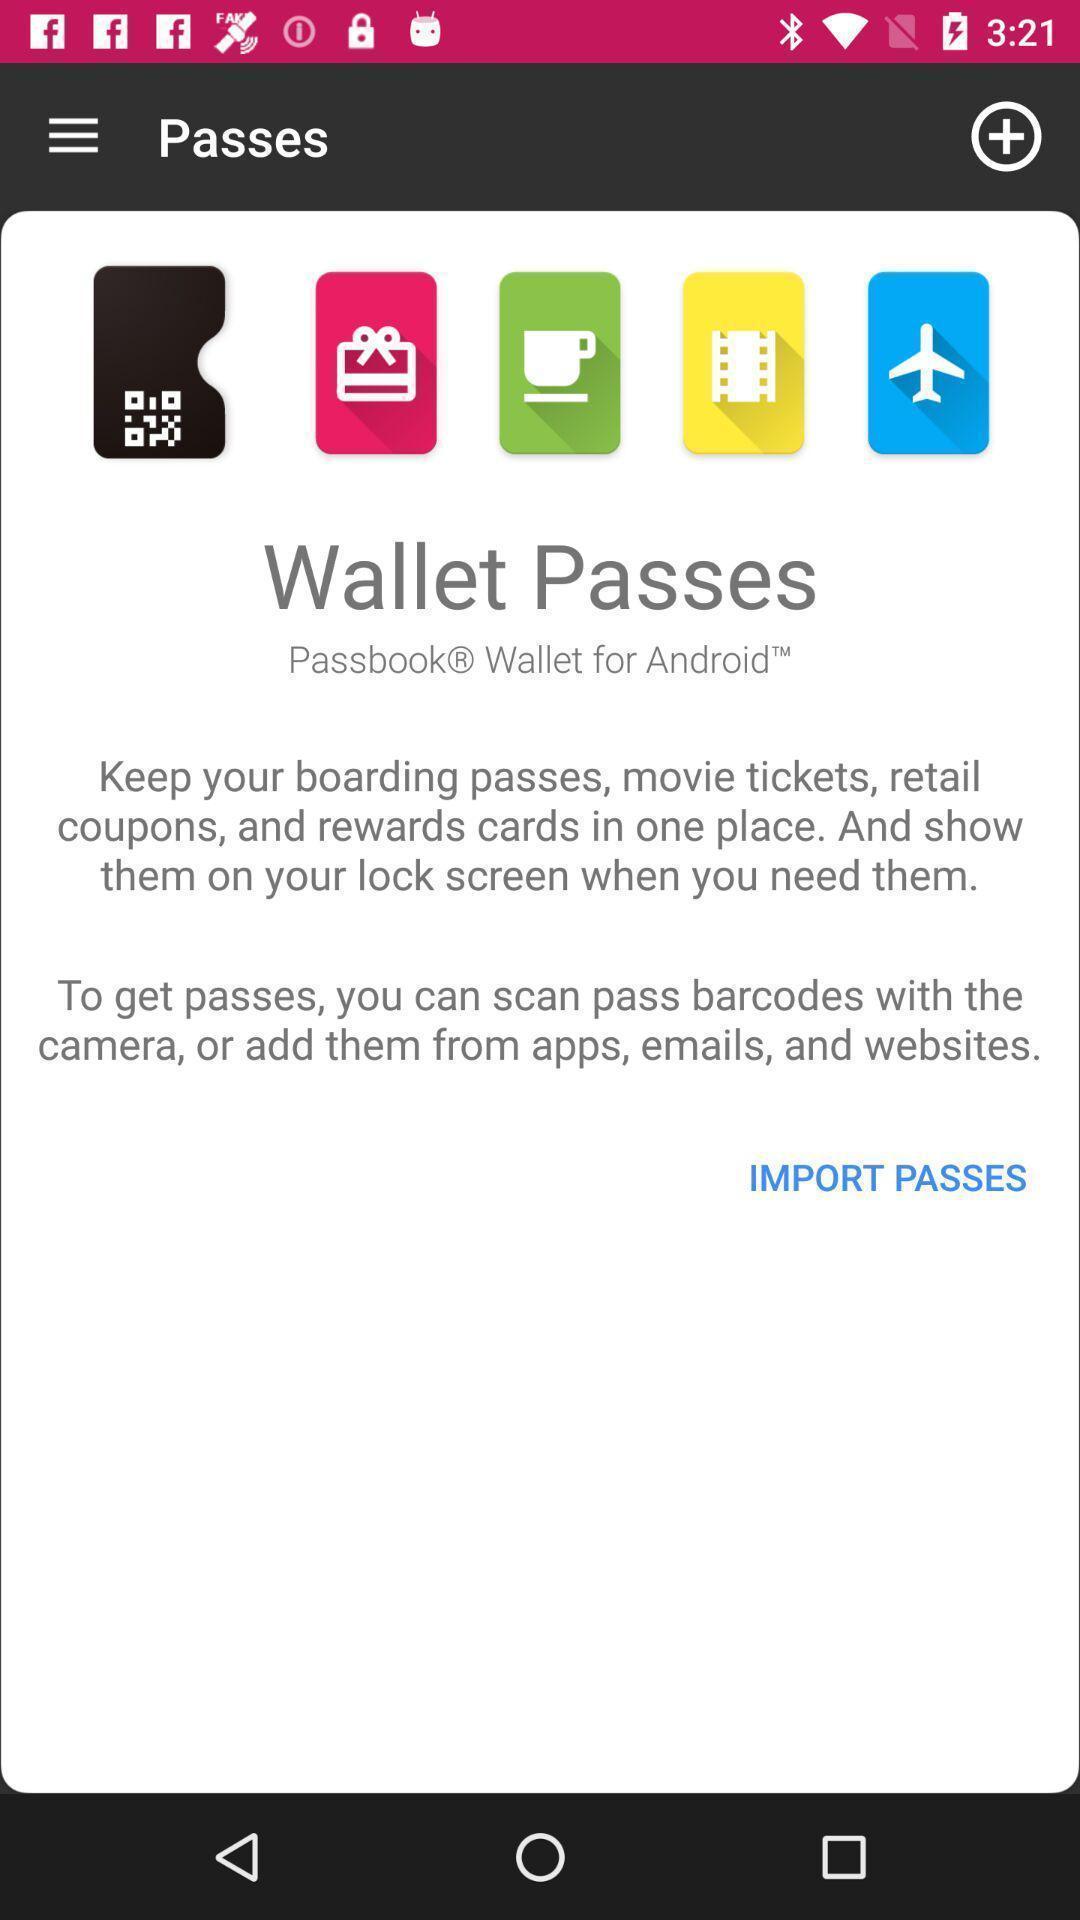Please provide a description for this image. Page wallet passes in the passes of app. 